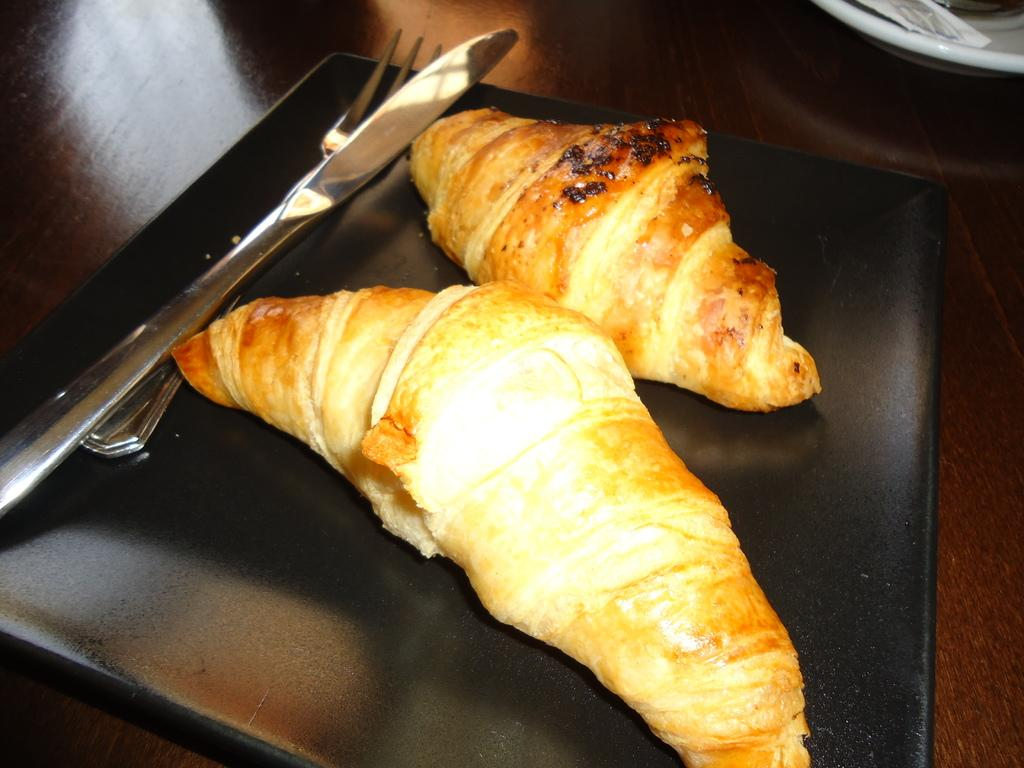What type of food can be seen in the image? There is a baked food in the image. Where is the baked food located? The baked food is on a surface. How many spoons are visible in the image? There are two spoons in the image. On which side of the image are the spoons located? The spoons are on the left side of the image. What type of vase is present on the right side of the image? There is no vase present in the image; it only features a baked food, a surface, and two spoons. 